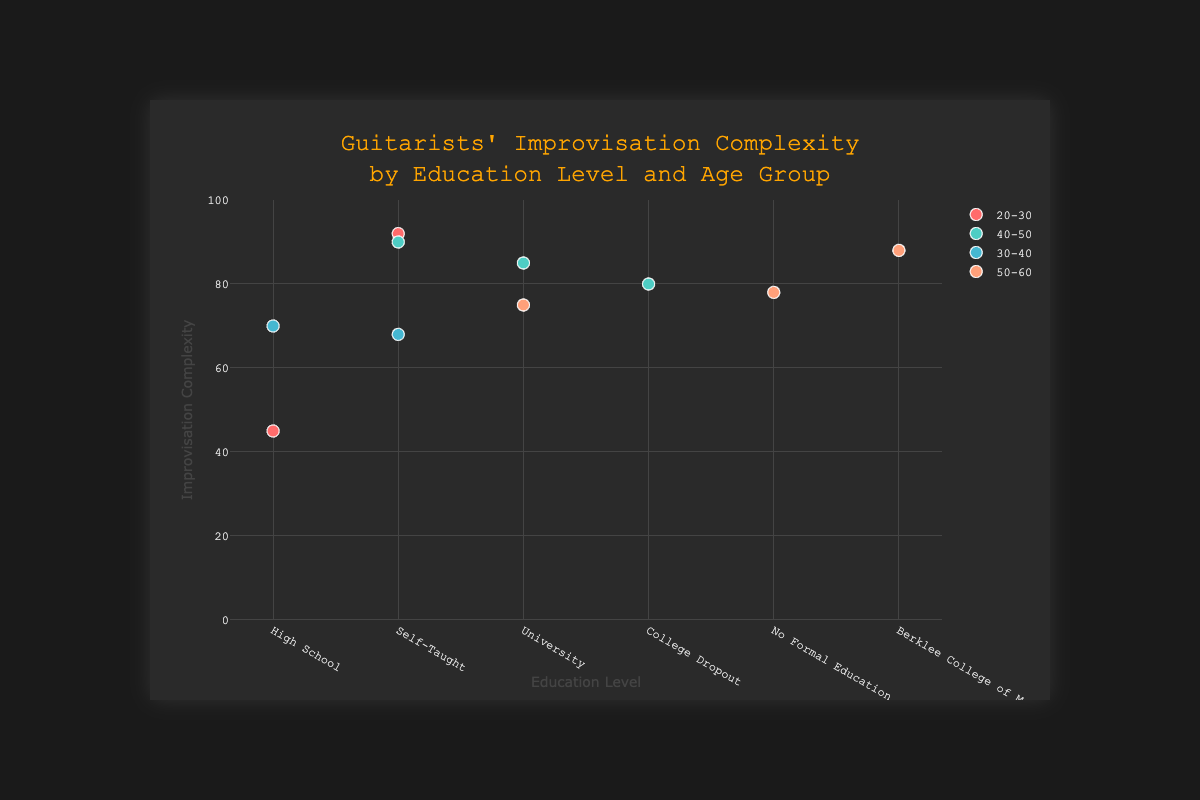What's the title of the figure? The title is located at the top center of the figure, and it reads 'Guitarists' Improvisation Complexity by Education Level and Age Group'.
Answer: Guitarists' Improvisation Complexity by Education Level and Age Group Which guitarist in the '20-30' age group has the highest improvisation complexity? In the '20-30' age group, there are two guitarists: John Mayer and Jimi Hendrix. Jimi Hendrix has an improvisation complexity of 92, which is higher than John Mayer's 45.
Answer: Jimi Hendrix What are the education levels shown on the x-axis? The x-axis displays distinct categories representing education levels, which are 'High School', 'University', 'Self-Taught', 'No Formal Education', 'College Dropout', and 'Berklee College of Music'.
Answer: High School, University, Self-Taught, No Formal Education, College Dropout, Berklee College of Music Who is the guitarist with the lowest improvisation complexity, and what is their education level? Looking across all data points, John Mayer has the lowest improvisation complexity of 45 and his education level is 'High School'.
Answer: John Mayer, High School What's the average improvisation complexity for the '40-50' age group? The '40-50' age group has three guitarists: Eric Clapton (85), Carlos Santana (80), and Joe Satriani (90). Their average improvisation complexity is (85 + 80 + 90) / 3 = 255 / 3 = 85.
Answer: 85 Which age group has the most guitarists with a 'Self-Taught' education level? There are three self-taught guitarists: Jimi Hendrix (20-30), Slash (30-40), and Joe Satriani (40-50). Therefore, every age group has an equal number of 'Self-Taught' guitarists.
Answer: 20-30, 30-40, 40-50 (equal) How does BB King's improvisation complexity compare to David Gilmour's? BB King, in the 50-60 age group with no formal education, has an improvisation complexity of 78. David Gilmour, in the same age group with a university education, has a complexity of 75. Comparing these, BB King's complexity (78) is slightly higher than David Gilmour's (75).
Answer: BB King's complexity is higher by 3 points Are there more guitarists aged '30-40' or '40-50'? From the data, there are two guitarists in the '30-40' age group (Chuck Berry and Slash) and three guitarists in the '40-50' age group (Eric Clapton, Carlos Santana, and Joe Satriani), so the '40-50' age group has more guitarists.
Answer: 40-50 Identify the guitarist in the '50-60' age group with the highest improvisation complexity and mention their education level. Within the '50-60' age group, the guitarists are BB King (78), David Gilmour (75), and Steve Vai (88). Steve Vai has the highest improvisation complexity of 88, and his education level is 'Berklee College of Music'.
Answer: Steve Vai, Berklee College of Music Which education level correlates with the highest average improvisation complexity? The guitarists’ improvisation complexities are grouped by education level and averaged: 
- High School (John Mayer: 45, Chuck Berry: 70) = (45 + 70) / 2 = 57.5
- University (Eric Clapton: 85, David Gilmour: 75) = (85 + 75) / 2 = 80
- Self-Taught (Jimi Hendrix: 92, Slash: 68, Joe Satriani: 90) = (92 + 68 + 90) / 3 = 83.33
- No Formal Education (BB King: 78) = 78
- College Dropout (Carlos Santana: 80) = 80
- Berklee College of Music (Steve Vai: 88) = 88
Therefore, 'Self-Taught' education correlates with the highest average improvisation complexity of 83.33.
Answer: Self-Taught 